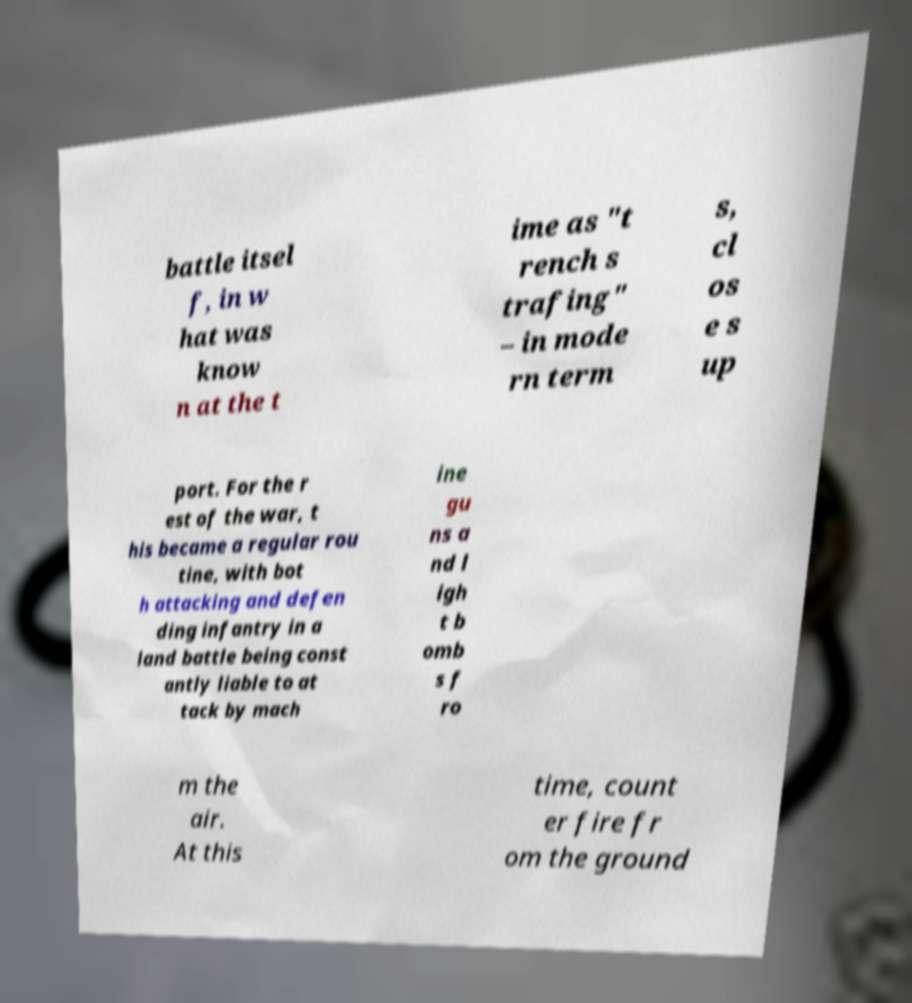There's text embedded in this image that I need extracted. Can you transcribe it verbatim? battle itsel f, in w hat was know n at the t ime as "t rench s trafing" – in mode rn term s, cl os e s up port. For the r est of the war, t his became a regular rou tine, with bot h attacking and defen ding infantry in a land battle being const antly liable to at tack by mach ine gu ns a nd l igh t b omb s f ro m the air. At this time, count er fire fr om the ground 